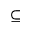Convert formula to latex. <formula><loc_0><loc_0><loc_500><loc_500>\subseteq</formula> 